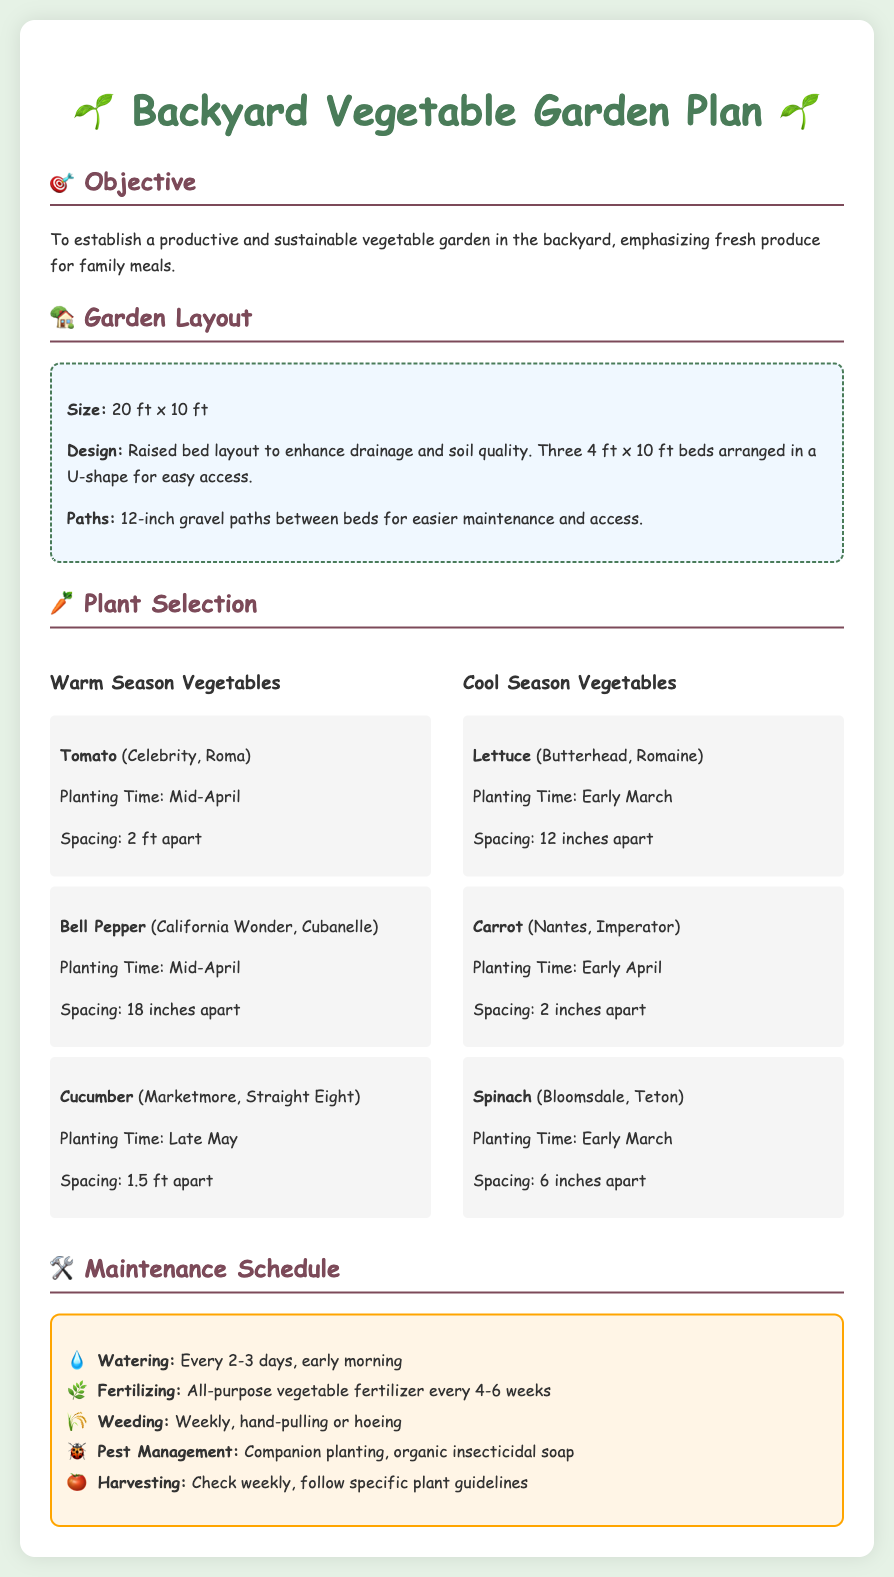What is the size of the garden? The size of the garden is specified in the document, which states it is 20 ft x 10 ft.
Answer: 20 ft x 10 ft What type of vegetables are grown in warm season? The document lists specific vegetables planted in warm season, including Tomato, Bell Pepper, and Cucumber.
Answer: Tomato, Bell Pepper, Cucumber When is the planting time for spinach? The document indicates the planting time for spinach as early March.
Answer: Early March What is the spacing for carrots? The document specifies the spacing for carrots is 2 inches apart.
Answer: 2 inches apart How often should the garden be watered? According to the maintenance schedule, the garden should be watered every 2-3 days.
Answer: Every 2-3 days What type of fertilizer is used? The document mentions using all-purpose vegetable fertilizer for the plants.
Answer: All-purpose vegetable fertilizer How wide are the paths between the beds? The paths between the beds, as per the document, are specified to be 12 inches wide.
Answer: 12 inches What is the objective of the garden plan? The objective of the garden plan is to establish a productive and sustainable vegetable garden for family meals.
Answer: Establish a productive and sustainable vegetable garden How often should weeding be done? The maintenance schedule specifies that weeding should be done weekly.
Answer: Weekly 